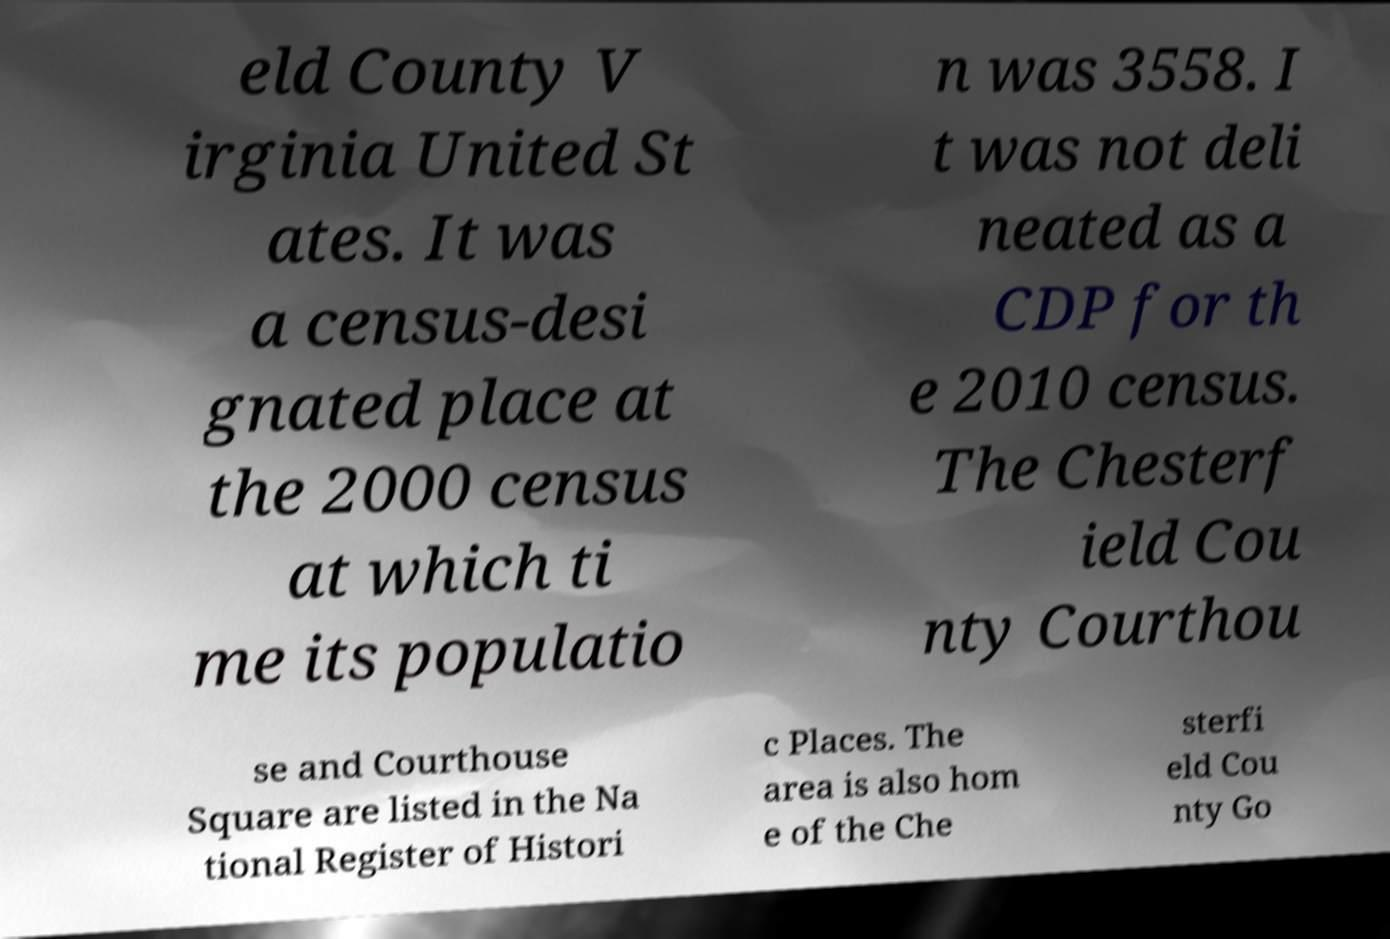Please read and relay the text visible in this image. What does it say? eld County V irginia United St ates. It was a census-desi gnated place at the 2000 census at which ti me its populatio n was 3558. I t was not deli neated as a CDP for th e 2010 census. The Chesterf ield Cou nty Courthou se and Courthouse Square are listed in the Na tional Register of Histori c Places. The area is also hom e of the Che sterfi eld Cou nty Go 